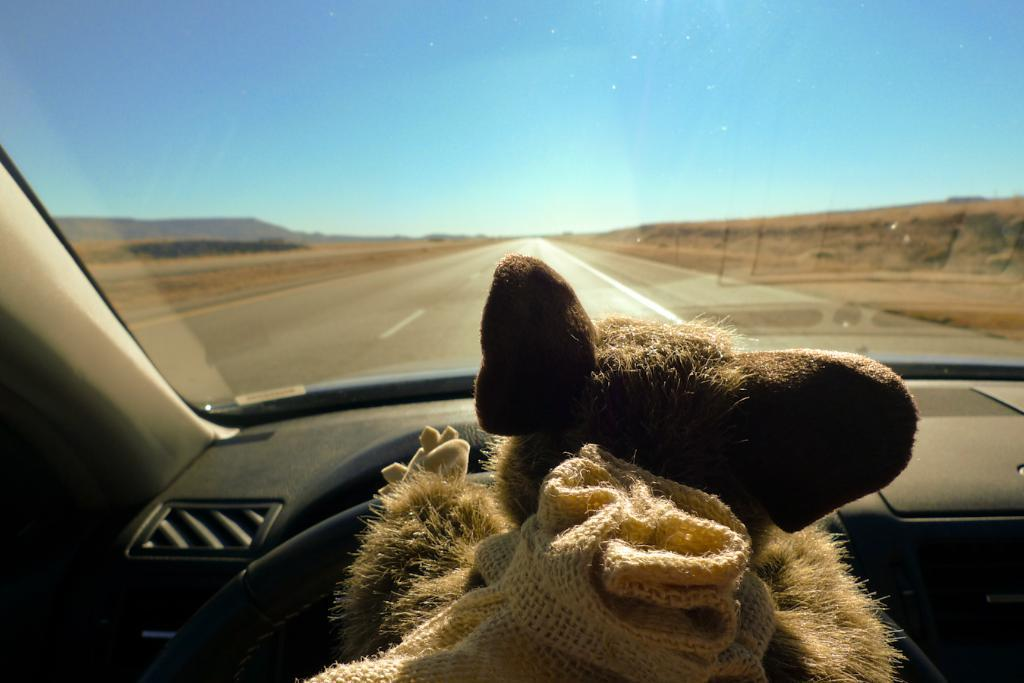What is the perspective of the image? The image is taken from inside a car. What can be seen on the steering wheel in the image? There is a toy on the steering wheel. What is visible in the background of the image? There is a road and the sky visible in the background. What book is the person reading while sleeping in the image? There is no person reading a book or sleeping in the image; it is taken from inside a car with a toy on the steering wheel. 